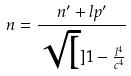Convert formula to latex. <formula><loc_0><loc_0><loc_500><loc_500>n = \frac { n ^ { \prime } + l p ^ { \prime } } { \sqrt { [ } ] { 1 - \frac { l ^ { 4 } } { c ^ { 4 } } } }</formula> 